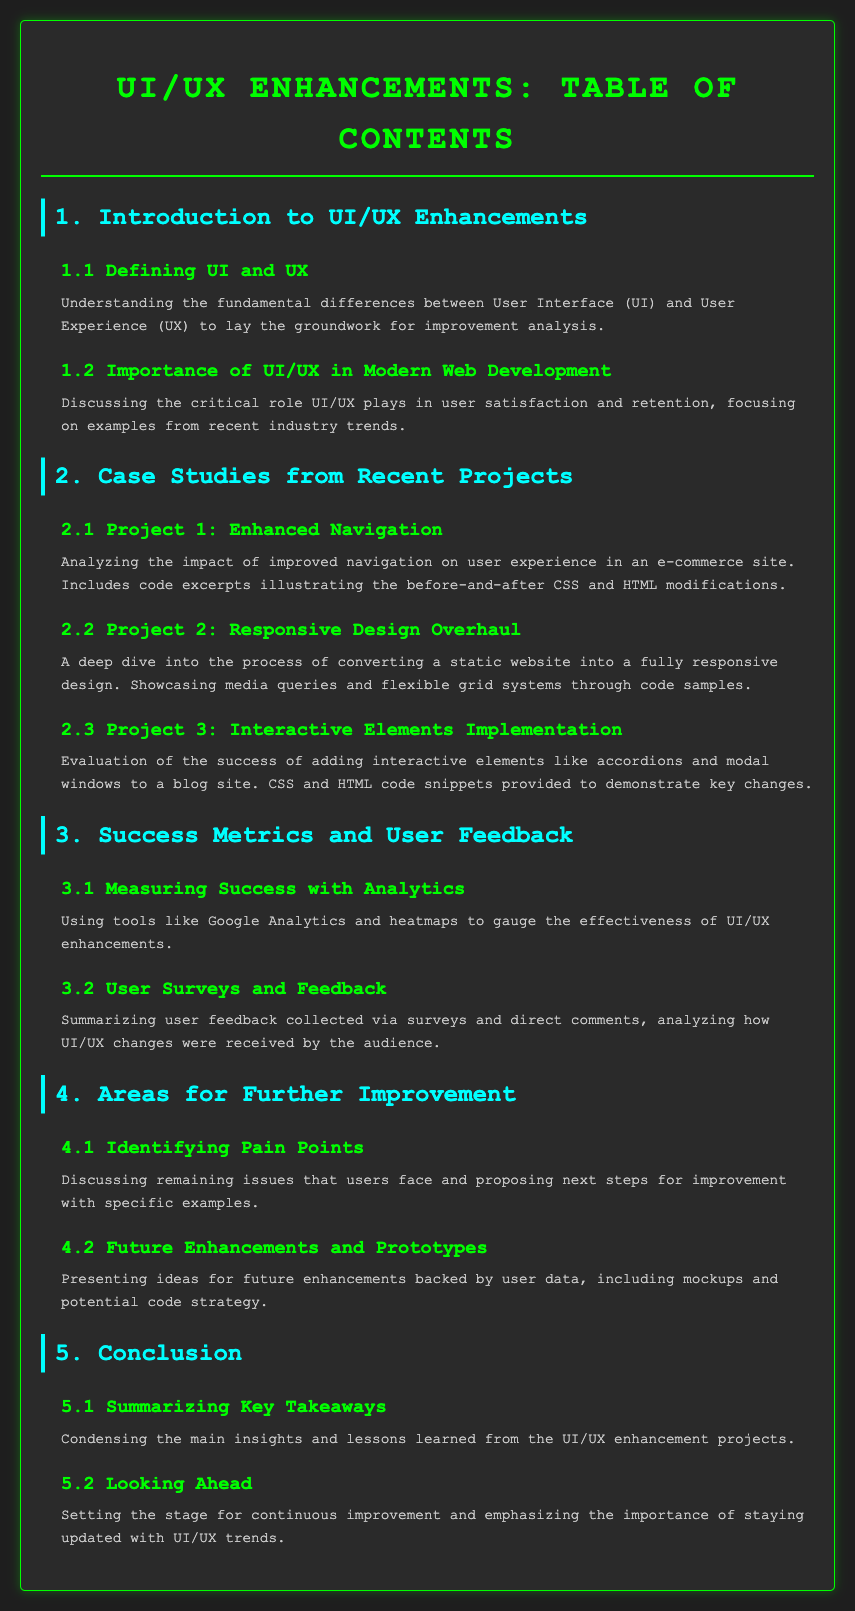What is the title of the document? The title of the document is specified in the <title> tag of the HTML code, which is "UI/UX Enhancements: Table of Contents".
Answer: UI/UX Enhancements: Table of Contents How many main sections are in the table of contents? The main sections are identified by the <h2> tags in the document, of which there are five listed in total.
Answer: 5 What type of project does section 2.1 focus on? Section 2.1 discusses a project that improved navigation on an e-commerce site, as indicated in the description provided.
Answer: Enhanced Navigation What section discusses the measuring of success with analytics? The section that focuses on measuring success is labeled as 3.1 and describes using analytics tools.
Answer: Measuring Success with Analytics What is a proposed topic for future enhancements mentioned in section 4.2? Section 4.2 presents ideas for future enhancements backed by user data, including mockups and potential code strategy.
Answer: Future Enhancements and Prototypes How many subsections are under section 1? The total number of subsections listed under section 1 is two, as mentioned by the numbers in the subsections.
Answer: 2 What color is used for the headings of subsections? The color for the subsection headings is specified in the CSS in the section for .toc-subsection h3.
Answer: Magenta What aspect of user feedback is summarized in section 3.2? Section 3.2 summarizes the user feedback collected via surveys and comments.
Answer: User Surveys and Feedback What does the conclusion section aim to summarize? The conclusion section aims to condense the main insights and lessons learned from the enhancement projects.
Answer: Key Takeaways 